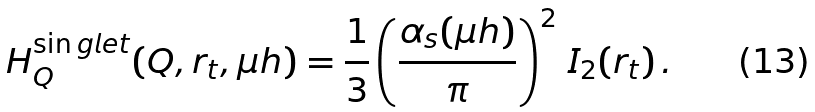<formula> <loc_0><loc_0><loc_500><loc_500>H _ { Q } ^ { \sin g l e t } ( Q , r _ { t } , \mu h ) = \frac { 1 } { 3 } \left ( \frac { \alpha _ { s } ( \mu h ) } { \pi } \right ) ^ { 2 } \, I _ { 2 } ( r _ { t } ) \, .</formula> 